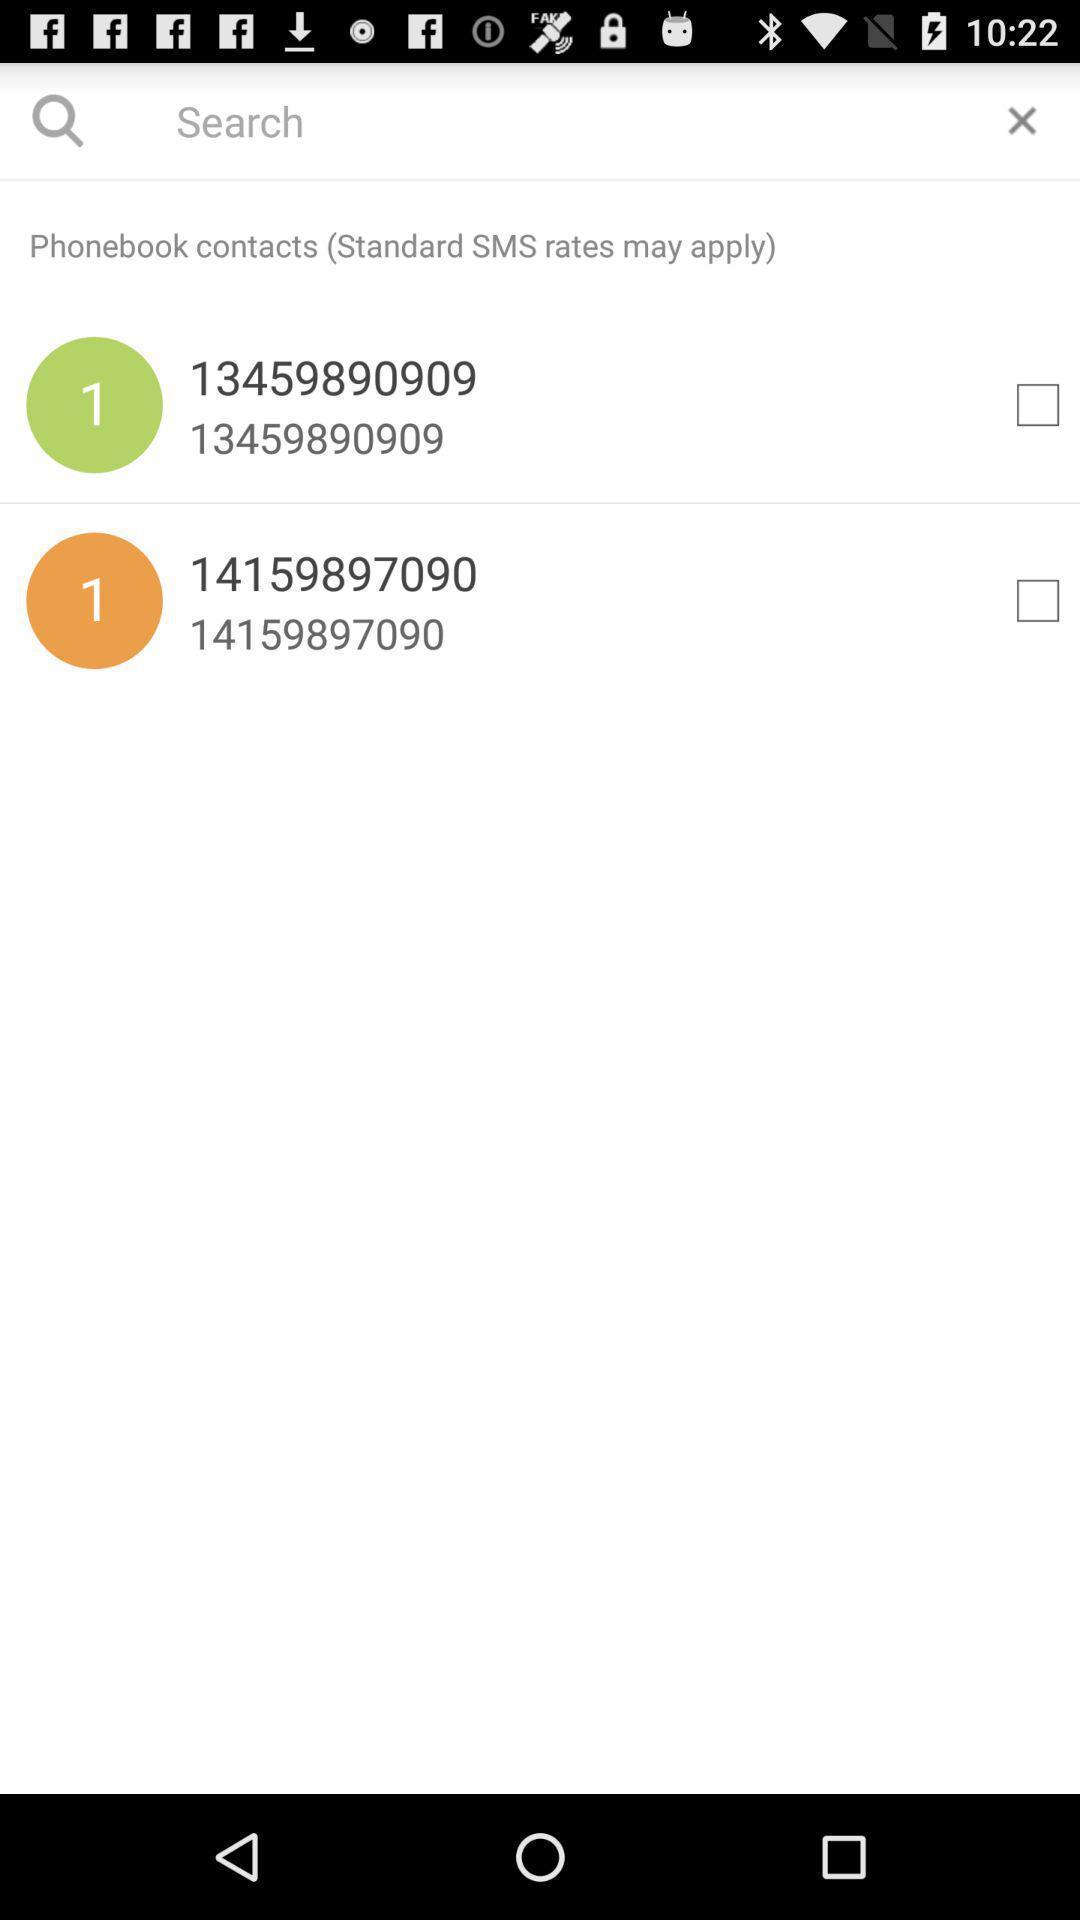Describe the content in this image. Page showing variety of numbers. 